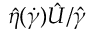<formula> <loc_0><loc_0><loc_500><loc_500>\hat { \eta } ( \dot { \gamma } ) \hat { U } / \hat { \gamma }</formula> 